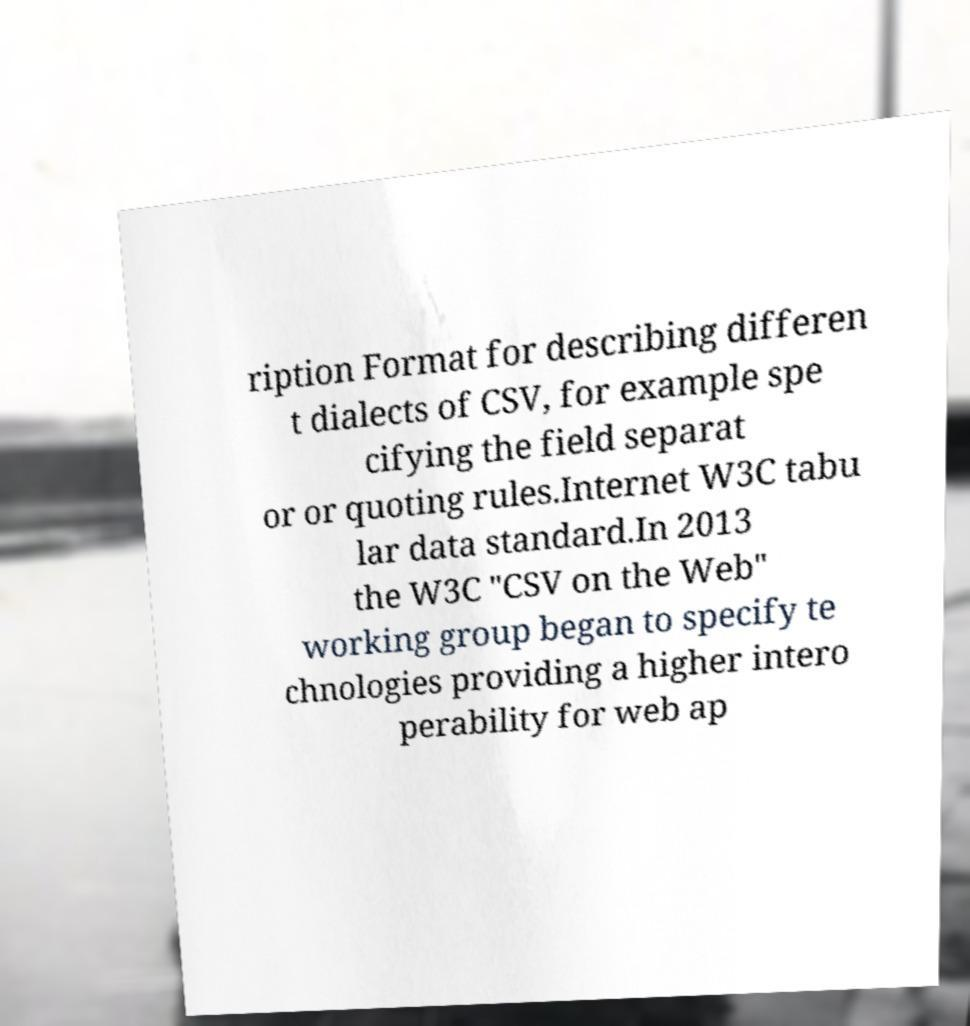Can you read and provide the text displayed in the image?This photo seems to have some interesting text. Can you extract and type it out for me? ription Format for describing differen t dialects of CSV, for example spe cifying the field separat or or quoting rules.Internet W3C tabu lar data standard.In 2013 the W3C "CSV on the Web" working group began to specify te chnologies providing a higher intero perability for web ap 